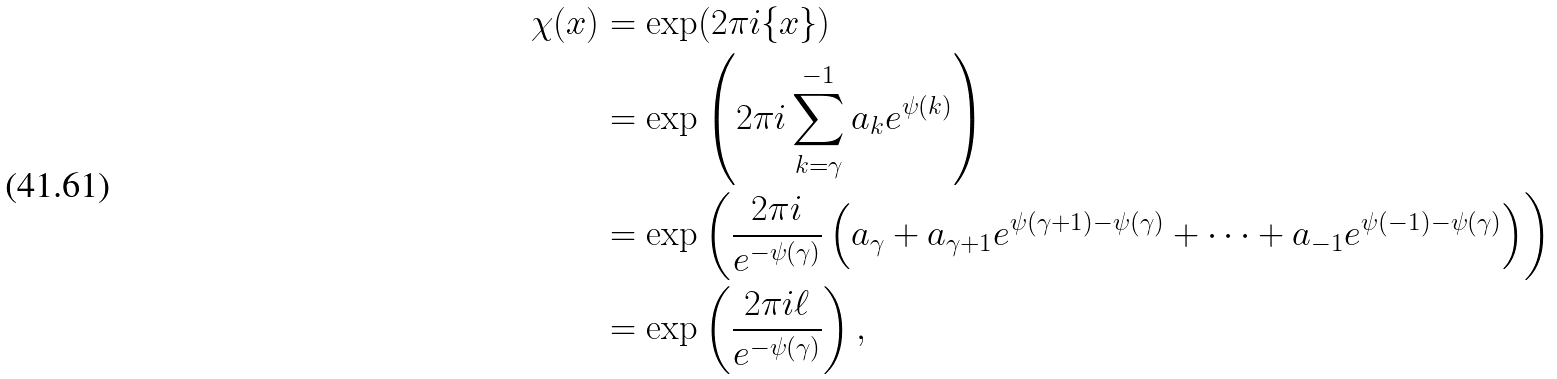<formula> <loc_0><loc_0><loc_500><loc_500>\chi ( x ) & = \exp ( 2 \pi i \{ x \} ) \\ & = \exp \left ( 2 \pi i \sum _ { k = \gamma } ^ { - 1 } a _ { k } e ^ { \psi ( k ) } \right ) \\ & = \exp \left ( \frac { 2 \pi i } { e ^ { - \psi ( \gamma ) } } \left ( a _ { \gamma } + a _ { \gamma + 1 } e ^ { \psi ( \gamma + 1 ) - \psi ( \gamma ) } + \cdots + a _ { - 1 } e ^ { \psi ( - 1 ) - \psi ( \gamma ) } \right ) \right ) \\ & = \exp \left ( \frac { 2 \pi i \ell } { e ^ { - \psi ( \gamma ) } } \right ) ,</formula> 